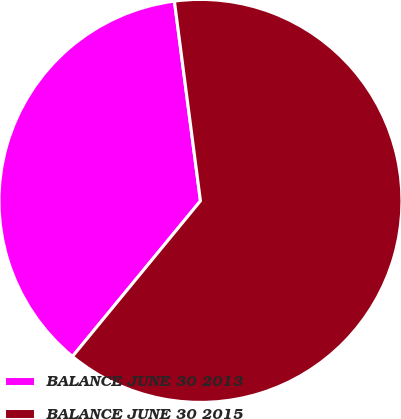<chart> <loc_0><loc_0><loc_500><loc_500><pie_chart><fcel>BALANCE JUNE 30 2013<fcel>BALANCE JUNE 30 2015<nl><fcel>36.98%<fcel>63.02%<nl></chart> 